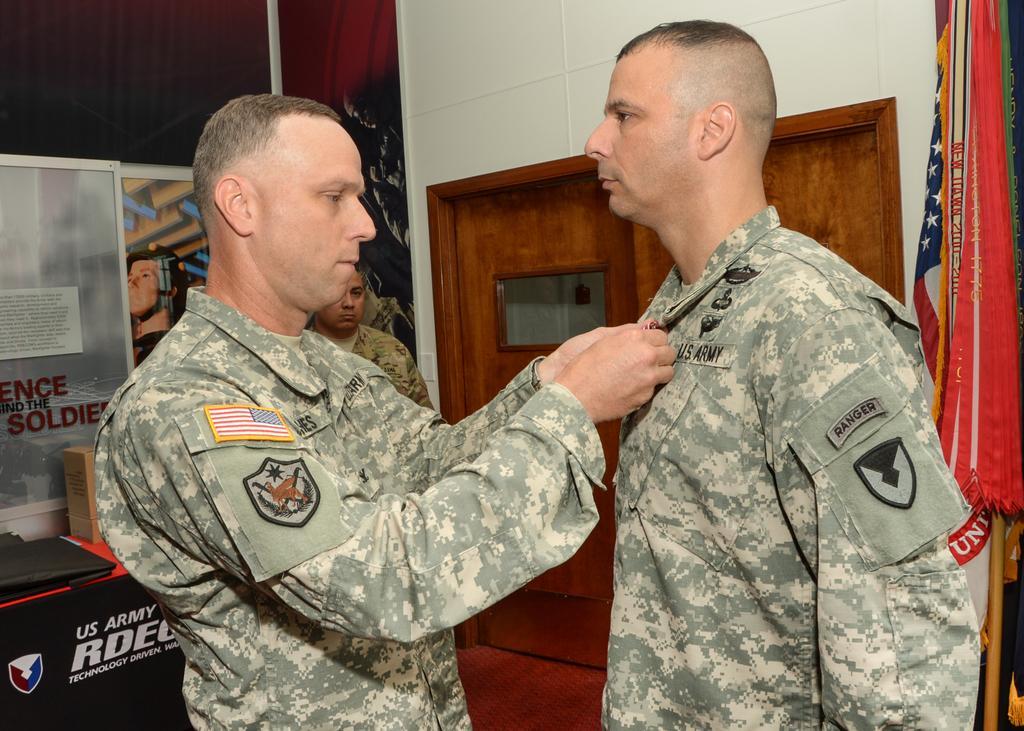Describe this image in one or two sentences. In this image I can see three persons standing wearing uniform which is in green color. Background I can see few papers attached to the wall, a wooden door, flag in blue, white and red color and the wall is in white color. 